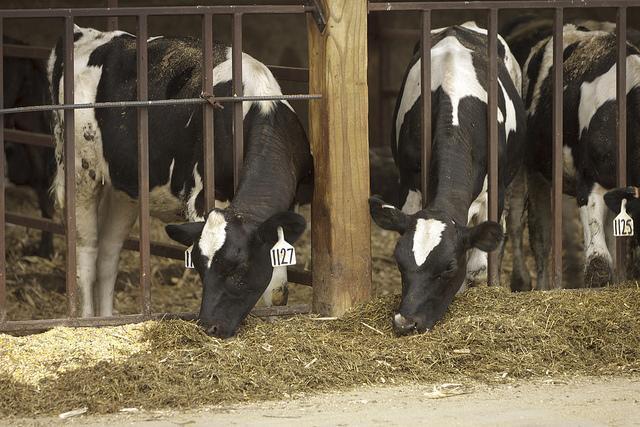How many cows are visible?
Give a very brief answer. 4. How many people are on top of elephants?
Give a very brief answer. 0. 